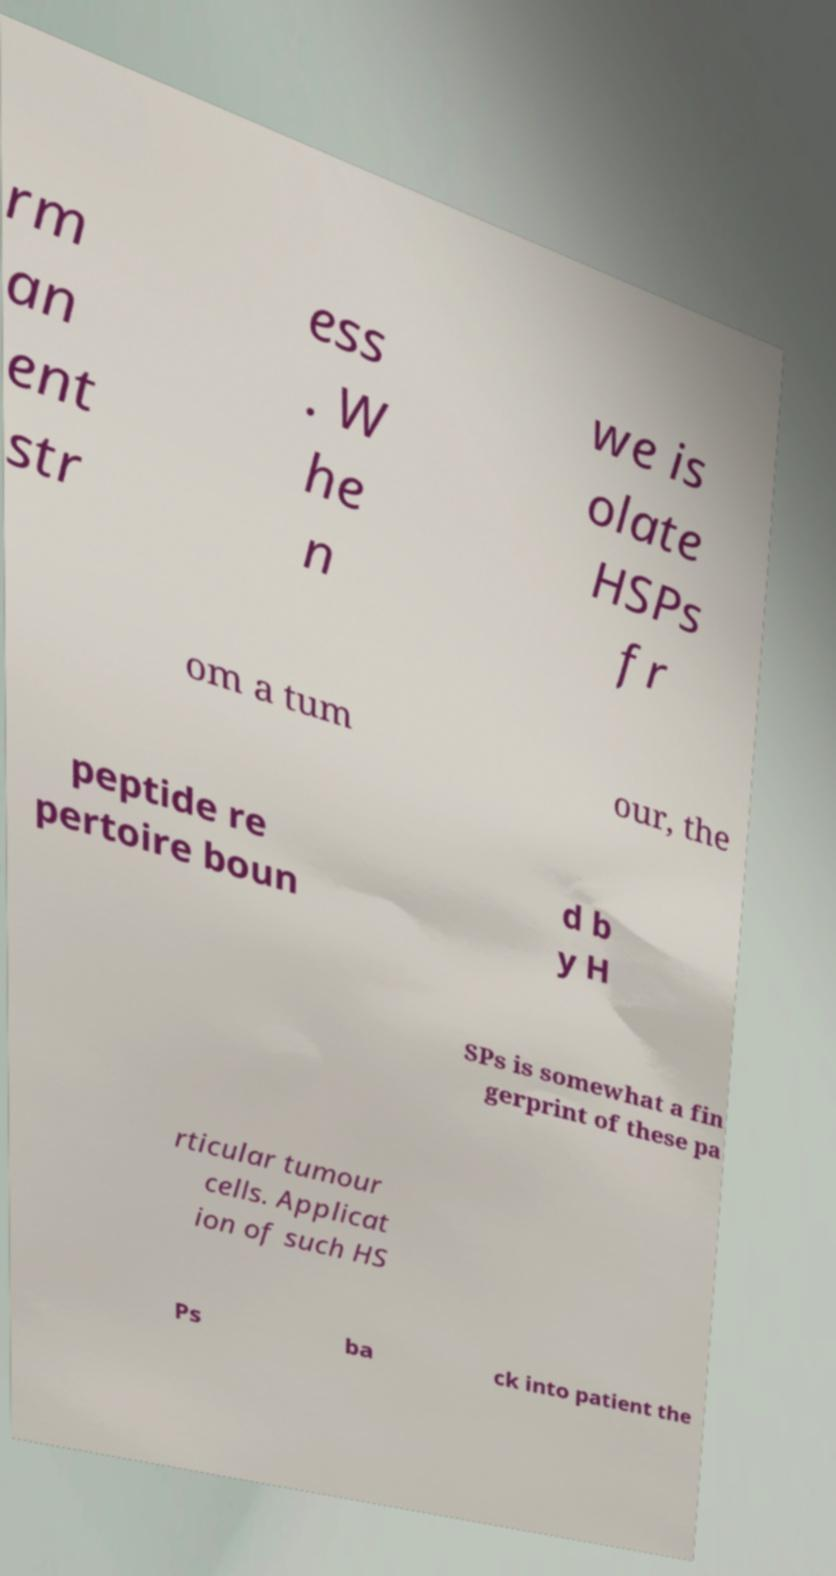I need the written content from this picture converted into text. Can you do that? rm an ent str ess . W he n we is olate HSPs fr om a tum our, the peptide re pertoire boun d b y H SPs is somewhat a fin gerprint of these pa rticular tumour cells. Applicat ion of such HS Ps ba ck into patient the 